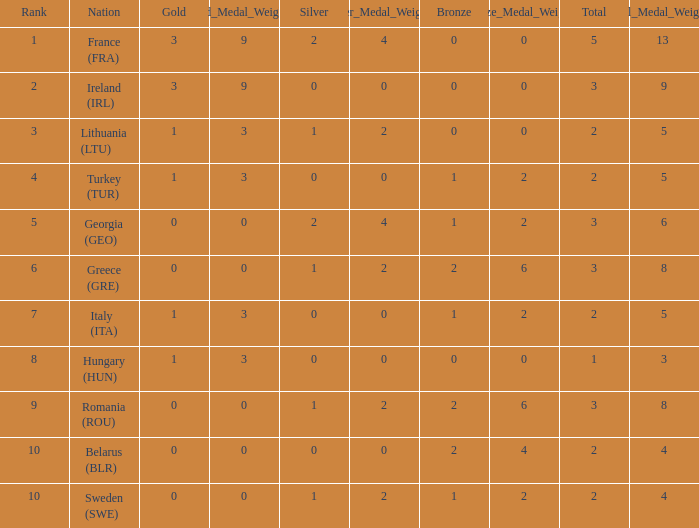What's the rank of Turkey (TUR) with a total more than 2? 0.0. 